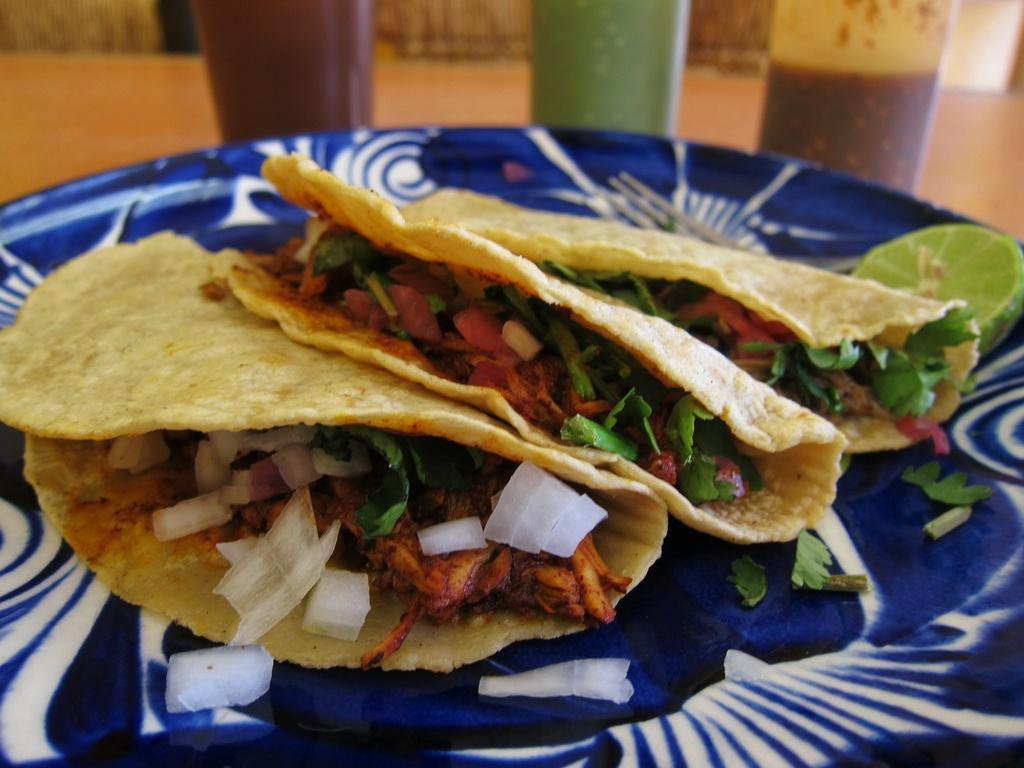In one or two sentences, can you explain what this image depicts? In the image we can see a plate, in the plate there is food. Behind the plate there are some glasses on the table. 